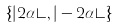Convert formula to latex. <formula><loc_0><loc_0><loc_500><loc_500>\{ | 2 \alpha \rangle , | - 2 \alpha \rangle \}</formula> 